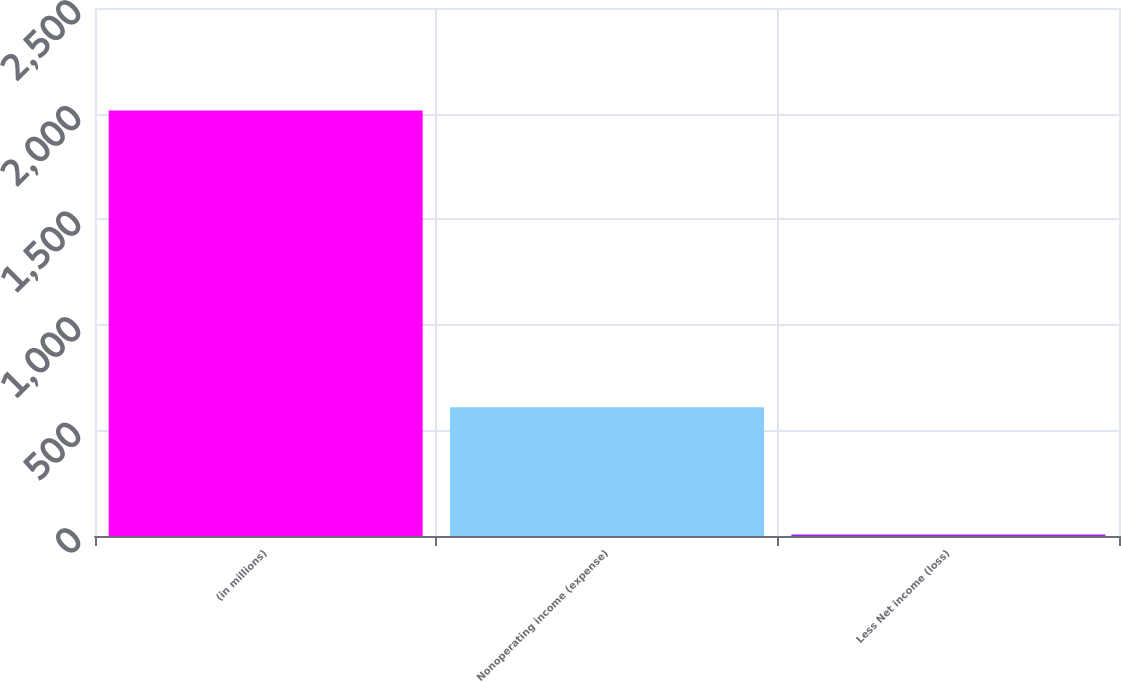Convert chart. <chart><loc_0><loc_0><loc_500><loc_500><bar_chart><fcel>(in millions)<fcel>Nonoperating income (expense)<fcel>Less Net income (loss)<nl><fcel>2015<fcel>609.4<fcel>7<nl></chart> 